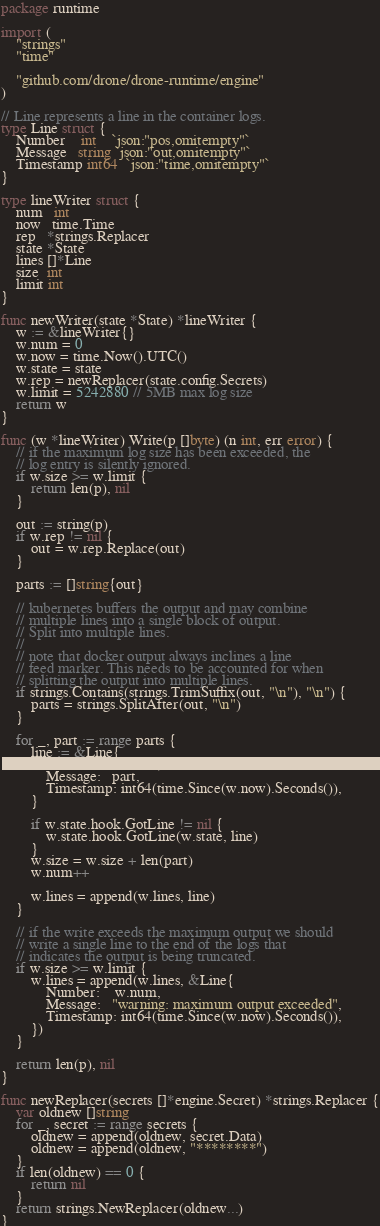<code> <loc_0><loc_0><loc_500><loc_500><_Go_>package runtime

import (
	"strings"
	"time"

	"github.com/drone/drone-runtime/engine"
)

// Line represents a line in the container logs.
type Line struct {
	Number    int    `json:"pos,omitempty"`
	Message   string `json:"out,omitempty"`
	Timestamp int64  `json:"time,omitempty"`
}

type lineWriter struct {
	num   int
	now   time.Time
	rep   *strings.Replacer
	state *State
	lines []*Line
	size  int
	limit int
}

func newWriter(state *State) *lineWriter {
	w := &lineWriter{}
	w.num = 0
	w.now = time.Now().UTC()
	w.state = state
	w.rep = newReplacer(state.config.Secrets)
	w.limit = 5242880 // 5MB max log size
	return w
}

func (w *lineWriter) Write(p []byte) (n int, err error) {
	// if the maximum log size has been exceeded, the
	// log entry is silently ignored.
	if w.size >= w.limit {
		return len(p), nil
	}

	out := string(p)
	if w.rep != nil {
		out = w.rep.Replace(out)
	}

	parts := []string{out}

	// kubernetes buffers the output and may combine
	// multiple lines into a single block of output.
	// Split into multiple lines.
	//
	// note that docker output always inclines a line
	// feed marker. This needs to be accounted for when
	// splitting the output into multiple lines.
	if strings.Contains(strings.TrimSuffix(out, "\n"), "\n") {
		parts = strings.SplitAfter(out, "\n")
	}

	for _, part := range parts {
		line := &Line{
			Number:    w.num,
			Message:   part,
			Timestamp: int64(time.Since(w.now).Seconds()),
		}

		if w.state.hook.GotLine != nil {
			w.state.hook.GotLine(w.state, line)
		}
		w.size = w.size + len(part)
		w.num++

		w.lines = append(w.lines, line)
	}

	// if the write exceeds the maximum output we should
	// write a single line to the end of the logs that
	// indicates the output is being truncated.
	if w.size >= w.limit {
		w.lines = append(w.lines, &Line{
			Number:    w.num,
			Message:   "warning: maximum output exceeded",
			Timestamp: int64(time.Since(w.now).Seconds()),
		})
	}

	return len(p), nil
}

func newReplacer(secrets []*engine.Secret) *strings.Replacer {
	var oldnew []string
	for _, secret := range secrets {
		oldnew = append(oldnew, secret.Data)
		oldnew = append(oldnew, "********")
	}
	if len(oldnew) == 0 {
		return nil
	}
	return strings.NewReplacer(oldnew...)
}
</code> 